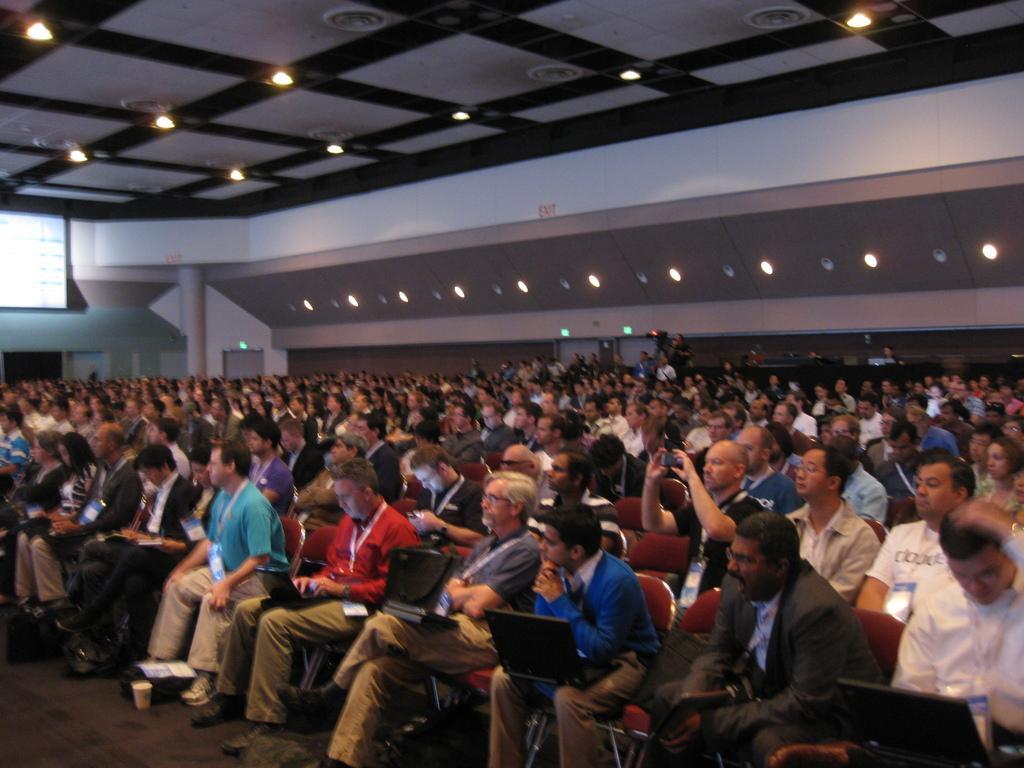Describe this image in one or two sentences. In this image, I can see a group of people sitting and few people standing. These are the lights. This looks like a pillar. On the left side of the image, I think this is the screen with the display. These are the ceiling lights, which are attached to the ceiling. I can see the laptop. This man is holding a mobile phone. 